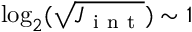<formula> <loc_0><loc_0><loc_500><loc_500>\log _ { 2 } ( \sqrt { J _ { i n t } } ) \sim 1</formula> 